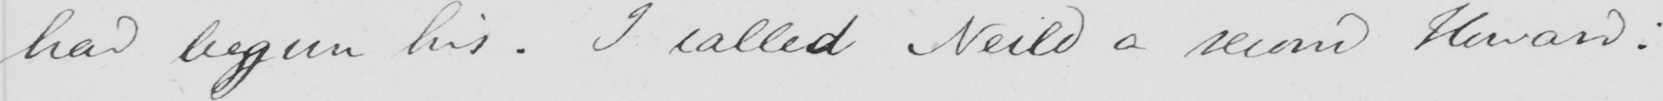Transcribe the text shown in this historical manuscript line. had begun his . I called Neild a second Howard : 